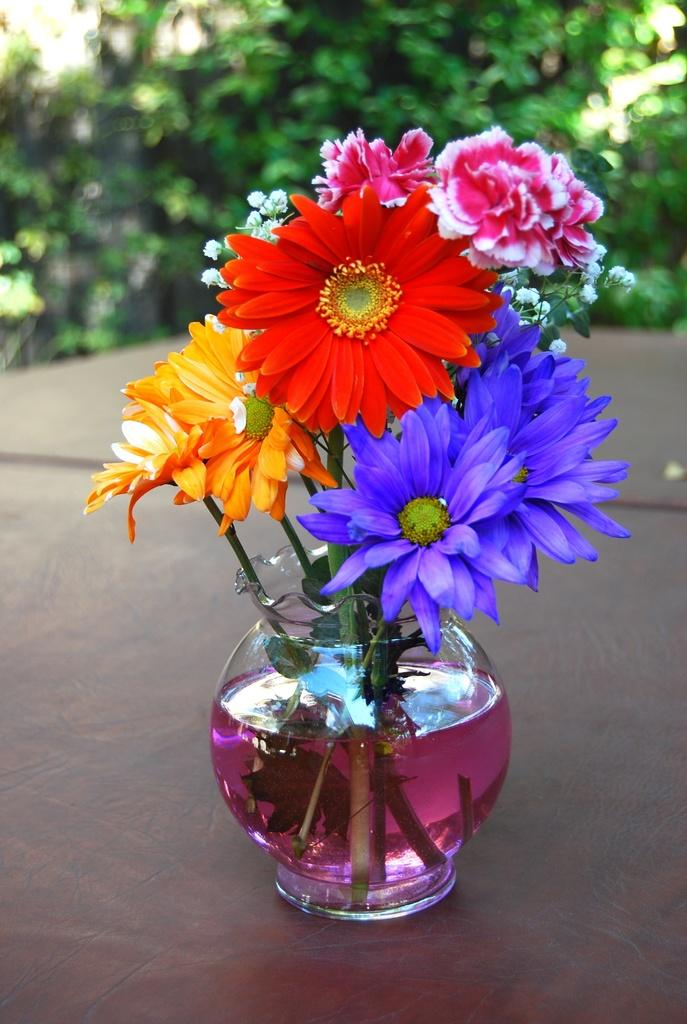What is present in the image that holds flowers? There is a flower vase in the image. What is inside the vase? There are flowers in the vase. What is used to keep the flowers hydrated in the vase? There is water in the vase. What type of vegetation can be seen in the background of the image? There are trees visible in the image. What type of metal badge can be seen on the flowers in the image? There is no metal badge present on the flowers in the image. What type of education is being provided to the flowers in the image? The flowers in the image are not receiving any education, as they are inanimate objects. 